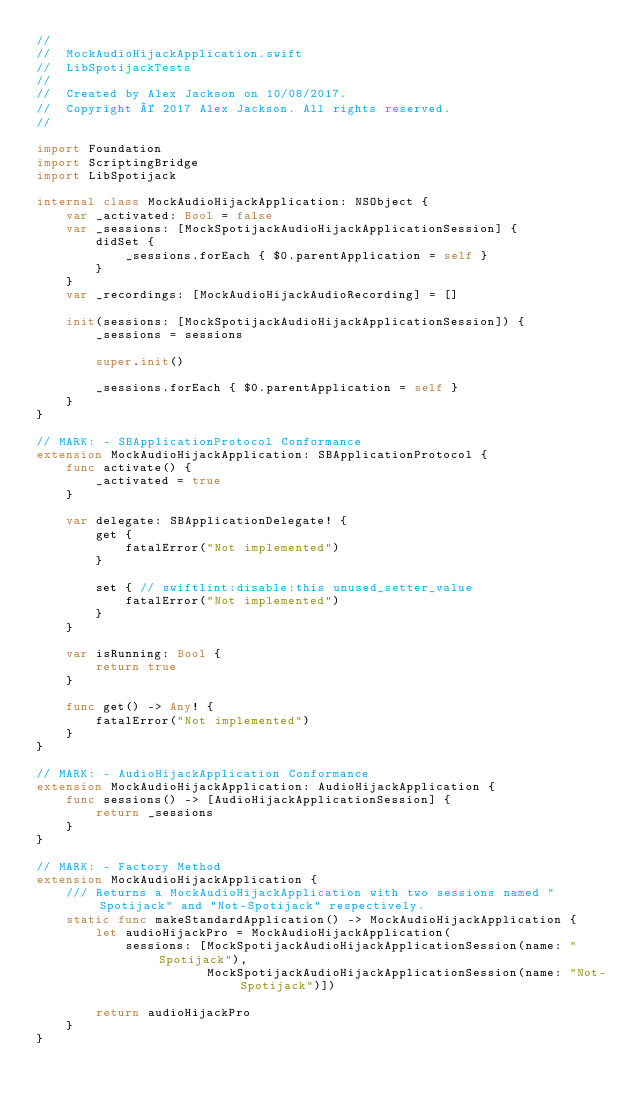Convert code to text. <code><loc_0><loc_0><loc_500><loc_500><_Swift_>//
//  MockAudioHijackApplication.swift
//  LibSpotijackTests
//
//  Created by Alex Jackson on 10/08/2017.
//  Copyright © 2017 Alex Jackson. All rights reserved.
//

import Foundation
import ScriptingBridge
import LibSpotijack

internal class MockAudioHijackApplication: NSObject {
    var _activated: Bool = false
    var _sessions: [MockSpotijackAudioHijackApplicationSession] {
        didSet {
            _sessions.forEach { $0.parentApplication = self }
        }
    }
    var _recordings: [MockAudioHijackAudioRecording] = []

    init(sessions: [MockSpotijackAudioHijackApplicationSession]) {
        _sessions = sessions

        super.init()

        _sessions.forEach { $0.parentApplication = self }
    }
}

// MARK: - SBApplicationProtocol Conformance
extension MockAudioHijackApplication: SBApplicationProtocol {
    func activate() {
        _activated = true
    }

    var delegate: SBApplicationDelegate! {
        get {
            fatalError("Not implemented")
        }

        set { // swiftlint:disable:this unused_setter_value
            fatalError("Not implemented")
        }
    }

    var isRunning: Bool {
        return true
    }

    func get() -> Any! {
        fatalError("Not implemented")
    }
}

// MARK: - AudioHijackApplication Conformance
extension MockAudioHijackApplication: AudioHijackApplication {
    func sessions() -> [AudioHijackApplicationSession] {
        return _sessions
    }
}

// MARK: - Factory Method
extension MockAudioHijackApplication {
    /// Returns a MockAudioHijackApplication with two sessions named "Spotijack" and "Not-Spotijack" respectively.
    static func makeStandardApplication() -> MockAudioHijackApplication {
        let audioHijackPro = MockAudioHijackApplication(
            sessions: [MockSpotijackAudioHijackApplicationSession(name: "Spotijack"),
                       MockSpotijackAudioHijackApplicationSession(name: "Not-Spotijack")])

        return audioHijackPro
    }
}
</code> 